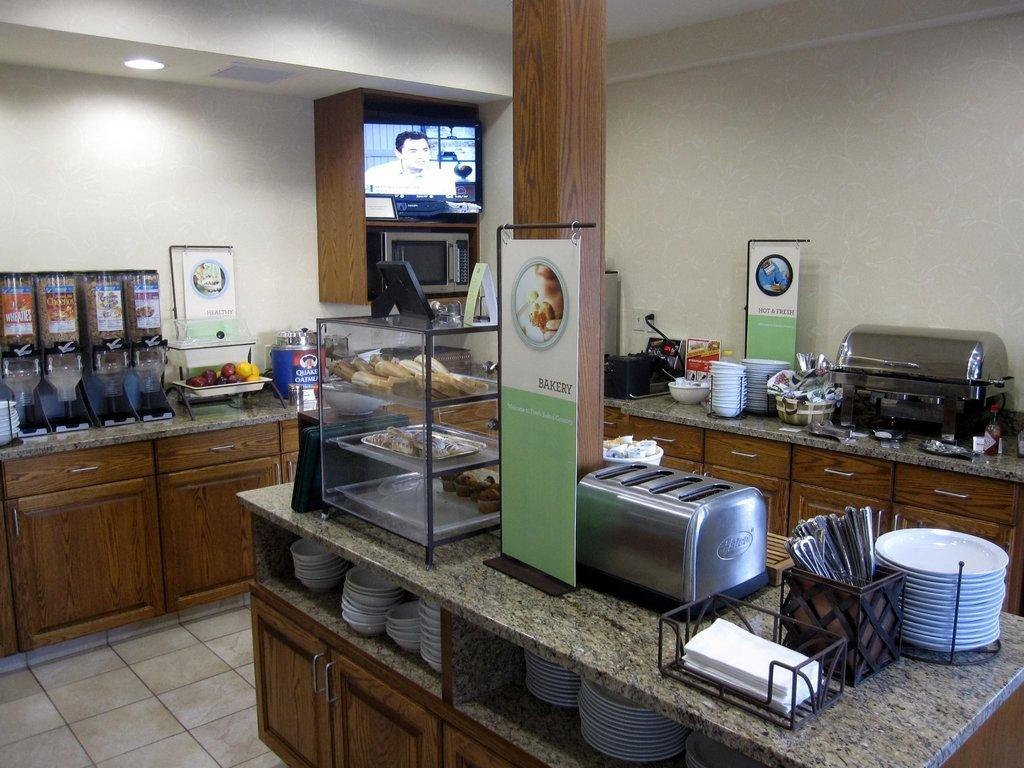<image>
Relay a brief, clear account of the picture shown. A restaurant's self serve area has a station for bakery items, hot and fresh options and healthy choices. 